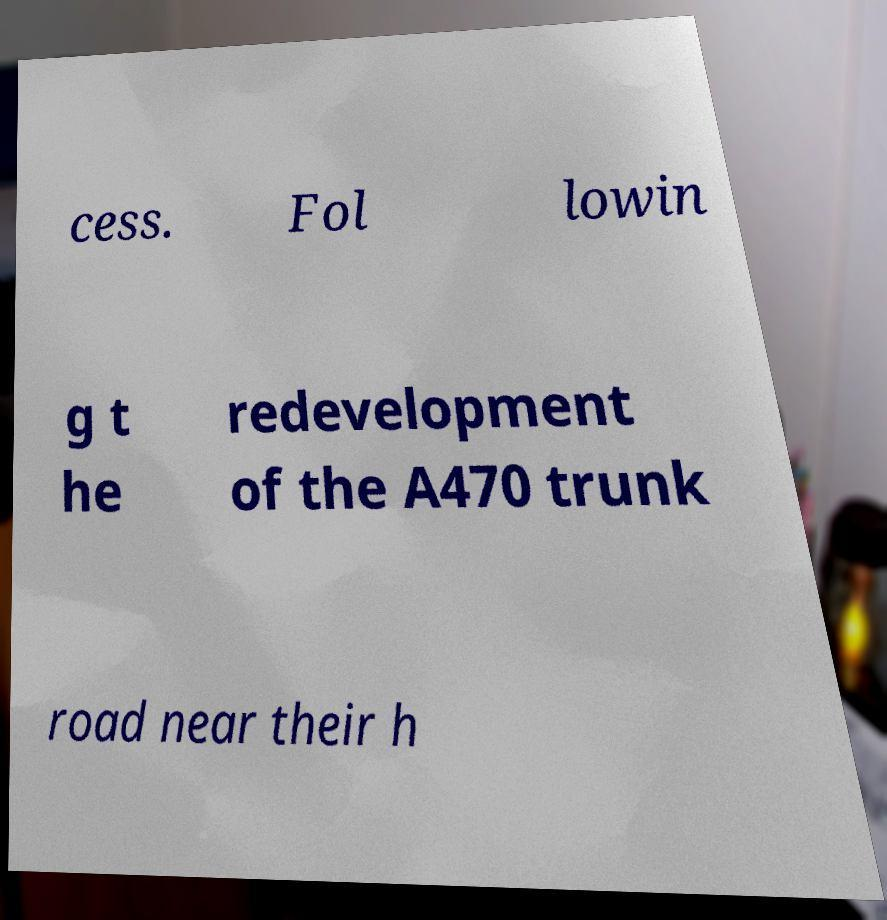Can you accurately transcribe the text from the provided image for me? cess. Fol lowin g t he redevelopment of the A470 trunk road near their h 